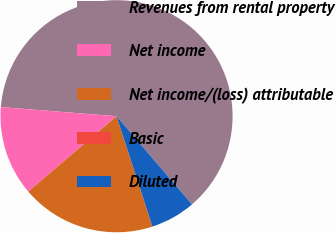Convert chart to OTSL. <chart><loc_0><loc_0><loc_500><loc_500><pie_chart><fcel>Revenues from rental property<fcel>Net income<fcel>Net income/(loss) attributable<fcel>Basic<fcel>Diluted<nl><fcel>62.48%<fcel>12.5%<fcel>18.75%<fcel>0.01%<fcel>6.26%<nl></chart> 